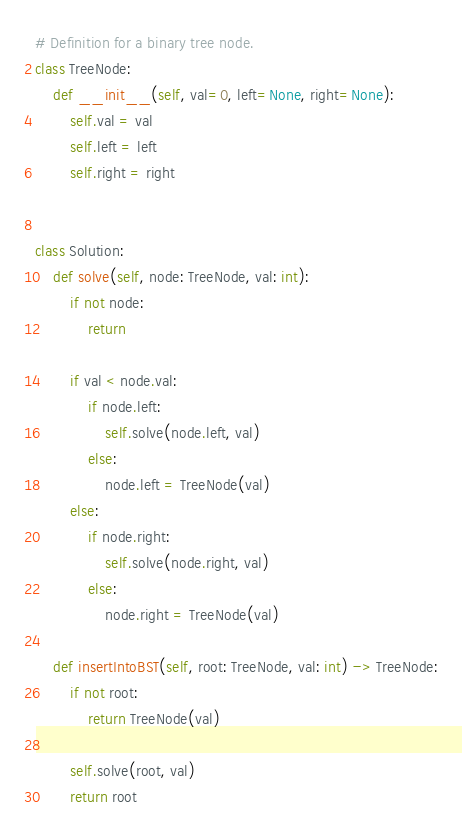<code> <loc_0><loc_0><loc_500><loc_500><_Python_># Definition for a binary tree node.
class TreeNode:
    def __init__(self, val=0, left=None, right=None):
        self.val = val
        self.left = left
        self.right = right


class Solution:
    def solve(self, node: TreeNode, val: int):
        if not node:
            return

        if val < node.val:
            if node.left:
                self.solve(node.left, val)
            else:
                node.left = TreeNode(val)
        else:
            if node.right:
                self.solve(node.right, val)
            else:
                node.right = TreeNode(val)

    def insertIntoBST(self, root: TreeNode, val: int) -> TreeNode:
        if not root:
            return TreeNode(val)

        self.solve(root, val)
        return root

</code> 